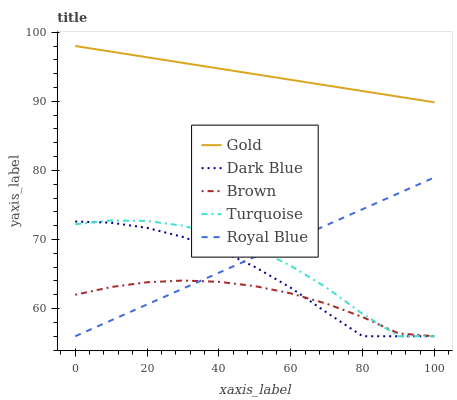Does Brown have the minimum area under the curve?
Answer yes or no. Yes. Does Gold have the maximum area under the curve?
Answer yes or no. Yes. Does Dark Blue have the minimum area under the curve?
Answer yes or no. No. Does Dark Blue have the maximum area under the curve?
Answer yes or no. No. Is Gold the smoothest?
Answer yes or no. Yes. Is Turquoise the roughest?
Answer yes or no. Yes. Is Dark Blue the smoothest?
Answer yes or no. No. Is Dark Blue the roughest?
Answer yes or no. No. Does Royal Blue have the lowest value?
Answer yes or no. Yes. Does Gold have the lowest value?
Answer yes or no. No. Does Gold have the highest value?
Answer yes or no. Yes. Does Dark Blue have the highest value?
Answer yes or no. No. Is Turquoise less than Gold?
Answer yes or no. Yes. Is Gold greater than Royal Blue?
Answer yes or no. Yes. Does Dark Blue intersect Turquoise?
Answer yes or no. Yes. Is Dark Blue less than Turquoise?
Answer yes or no. No. Is Dark Blue greater than Turquoise?
Answer yes or no. No. Does Turquoise intersect Gold?
Answer yes or no. No. 